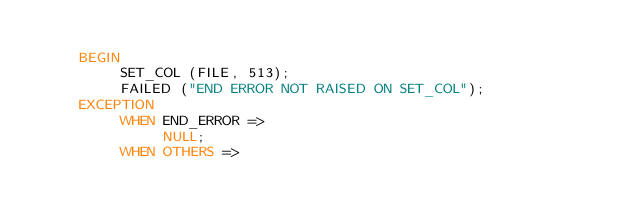<code> <loc_0><loc_0><loc_500><loc_500><_Ada_>
     BEGIN
          SET_COL (FILE, 513);
          FAILED ("END ERROR NOT RAISED ON SET_COL");
     EXCEPTION
          WHEN END_ERROR =>
               NULL;
          WHEN OTHERS =></code> 